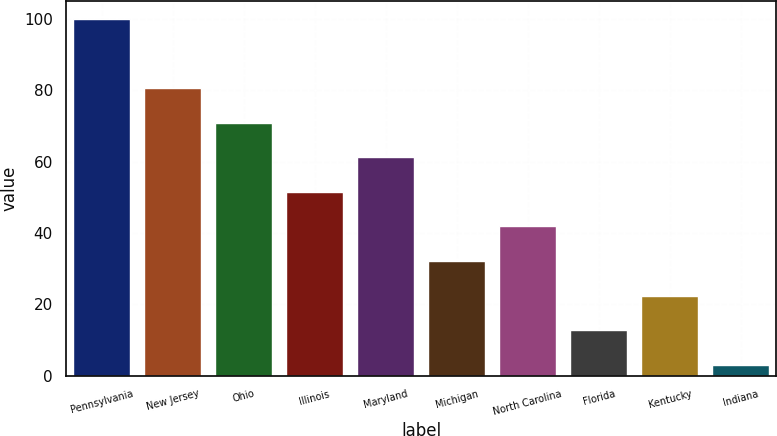<chart> <loc_0><loc_0><loc_500><loc_500><bar_chart><fcel>Pennsylvania<fcel>New Jersey<fcel>Ohio<fcel>Illinois<fcel>Maryland<fcel>Michigan<fcel>North Carolina<fcel>Florida<fcel>Kentucky<fcel>Indiana<nl><fcel>100<fcel>80.6<fcel>70.9<fcel>51.5<fcel>61.2<fcel>32.1<fcel>41.8<fcel>12.7<fcel>22.4<fcel>3<nl></chart> 